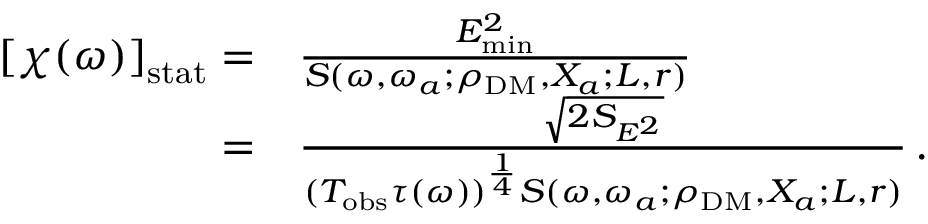<formula> <loc_0><loc_0><loc_500><loc_500>\begin{array} { r l } { \left [ \chi ( \omega ) \right ] _ { s t a t } = } & { \frac { E _ { \min } ^ { 2 } } { S ( \omega , \omega _ { a } ; \rho _ { D M } , X _ { a } ; L , r ) } \, } \\ { = } & { \frac { \sqrt { 2 S _ { E ^ { 2 } } } } { ( T _ { o b s } \tau ( \omega ) ) ^ { \frac { 1 } { 4 } } S ( \omega , \omega _ { a } ; \rho _ { D M } , X _ { a } ; L , r ) } \, . } \end{array}</formula> 